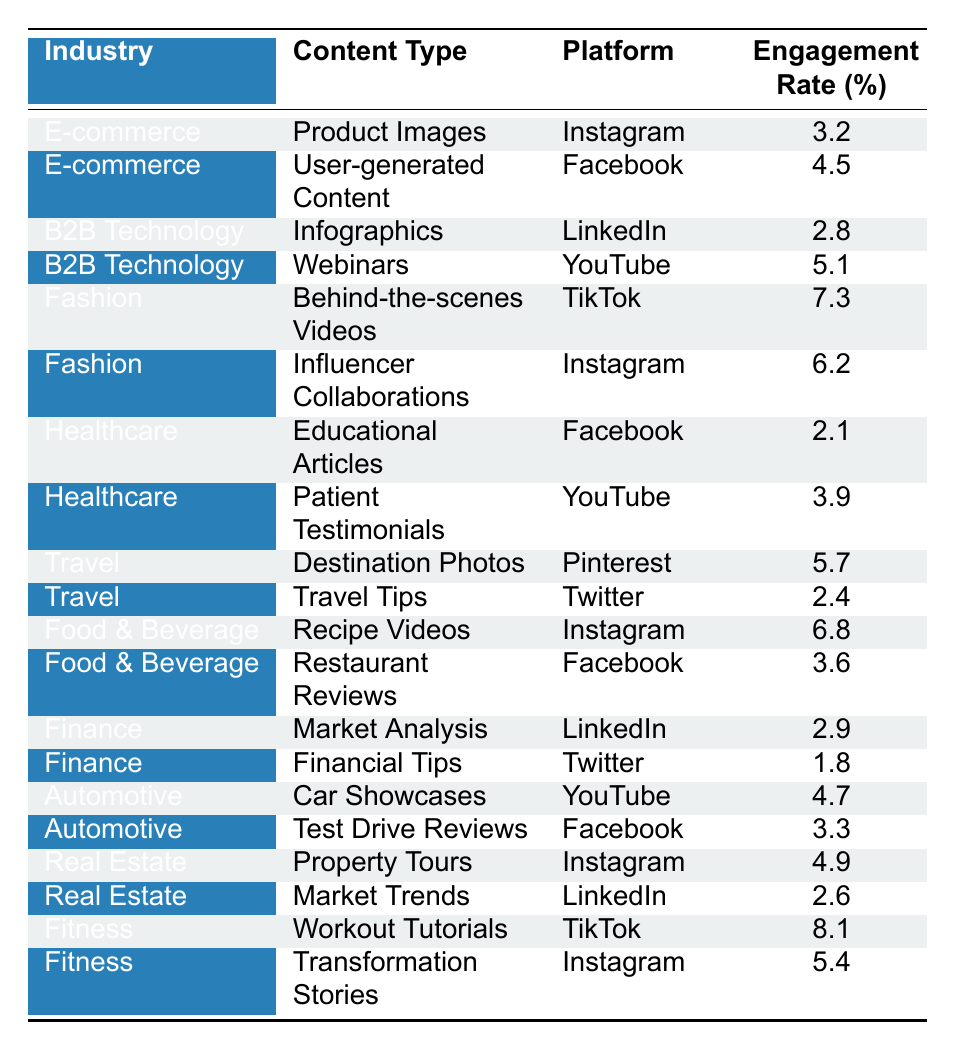What is the highest engagement rate for content in the Fitness industry? The table shows that the highest engagement rate for Fitness content is 8.1%, which corresponds to "Workout Tutorials" on TikTok.
Answer: 8.1% Which platform has the highest engagement rate for Financial content? For the Finance industry, the highest engagement rate is 2.9% for "Market Analysis" on LinkedIn.
Answer: LinkedIn Is the engagement rate for User-generated Content in E-commerce higher than the average engagement rate of all content types in Healthcare? The engagement rate for User-generated Content in E-commerce is 4.5%. The average for Healthcare (2.1% + 3.9%) / 2 = 3.0%. Since 4.5% is greater than 3.0%, the answer is yes.
Answer: Yes What is the total engagement rate for Content Types in the Food & Beverage industry? The engagement rates for Food & Beverage are 6.8% (Recipe Videos) and 3.6% (Restaurant Reviews). Summing these gives 6.8% + 3.6% = 10.4%.
Answer: 10.4% Which industry and content type combination has the lowest engagement rate? The Healthcare industry with "Educational Articles" has the lowest engagement rate of 2.1%.
Answer: Healthcare, Educational Articles What is the average engagement rate for the B2B Technology industry? B2B Technology has two content types: Infographics (2.8%) and Webinars (5.1%). The average engagement rate is (2.8% + 5.1%) / 2 = 3.95%.
Answer: 3.95% Does the Fashion industry have any content type with an engagement rate over 7%? The engagement rate for "Behind-the-scenes Videos" in Fashion is 7.3%, which confirms there is at least one content type exceeding 7%.
Answer: Yes Which industry shows the greatest variety of content types in terms of engagement rates? By analyzing the table, the E-commerce, Fashion, and Healthcare industries all show different types with multiple engagement rates, but Fashion has a wider spread between its highest (7.3%) and lowest (6.2%).
Answer: Fashion What content type in the Travel industry has the highest engagement rate, and what is that rate? "Destination Photos" in the Travel industry has the highest engagement rate at 5.7%.
Answer: Destination Photos, 5.7% Are there any content types that are common between the Instagram platform and the Food & Beverage industry? The table lists Recipe Videos for Food & Beverage on Instagram, confirming this content type is present on the platform.
Answer: Yes 